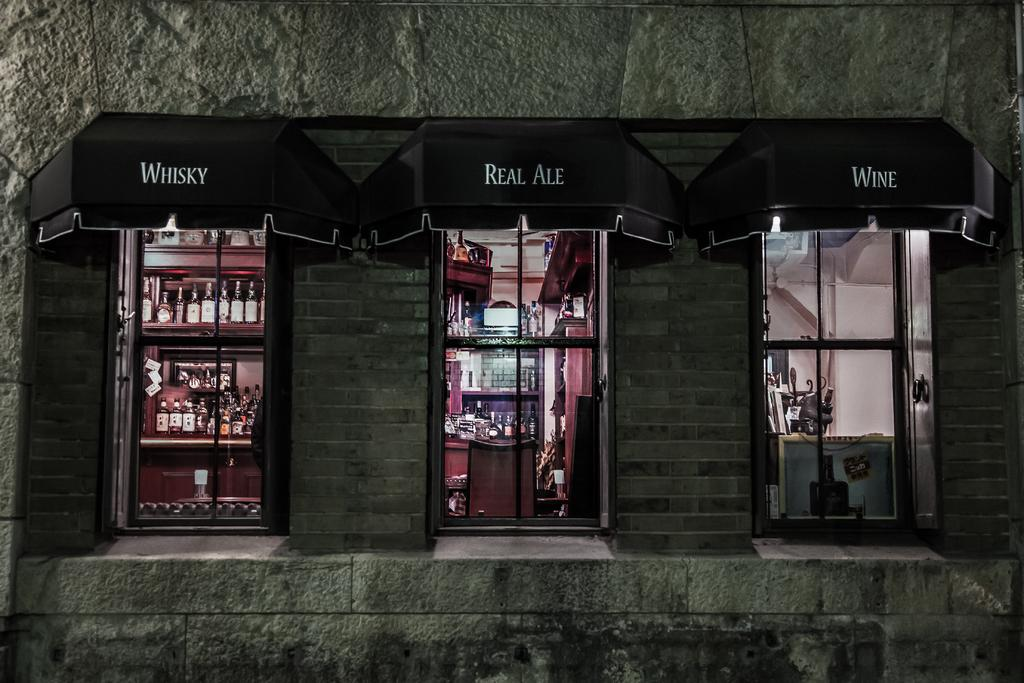What can be seen on the building wall in the image? There are three windows on the building wall in the image. What is written on the black roof in the image? There is text on a black roof in the image. What type of objects are stored in racks in the image? There are bottles in racks in the image. Can you describe the interior of the building in the image? There are objects inside the building in the image. Is there a bomb visible in the image? No, there is no bomb present in the image. What thought process is the building having in the image? Buildings do not have thought processes, as they are inanimate objects. 